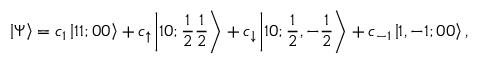<formula> <loc_0><loc_0><loc_500><loc_500>\left | \Psi \right \rangle = c _ { 1 } \left | 1 1 ; 0 0 \right \rangle + c _ { \uparrow } \left | 1 0 ; \frac { 1 } { 2 } \frac { 1 } { 2 } \right \rangle + c _ { \downarrow } \left | 1 0 ; \frac { 1 } { 2 } , { - } \frac { 1 } { 2 } \right \rangle + c _ { { - } 1 } \left | 1 , - 1 ; 0 0 \right \rangle ,</formula> 